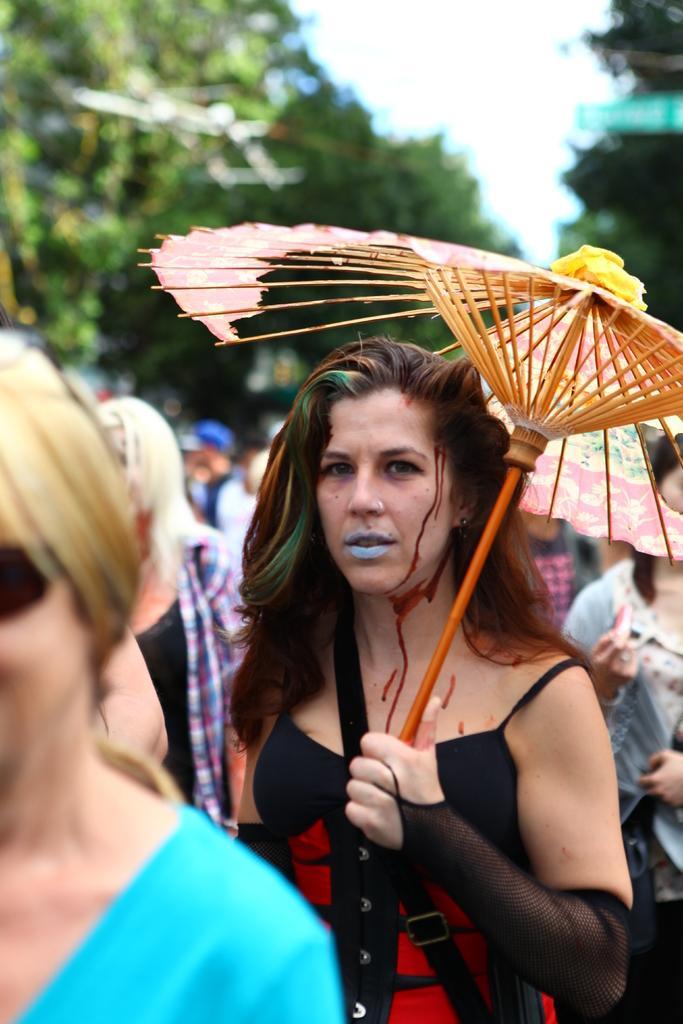Please provide a concise description of this image. In this image there is a woman standing and holding an umbrella, and in the background there are group of people standing, trees,sky. 